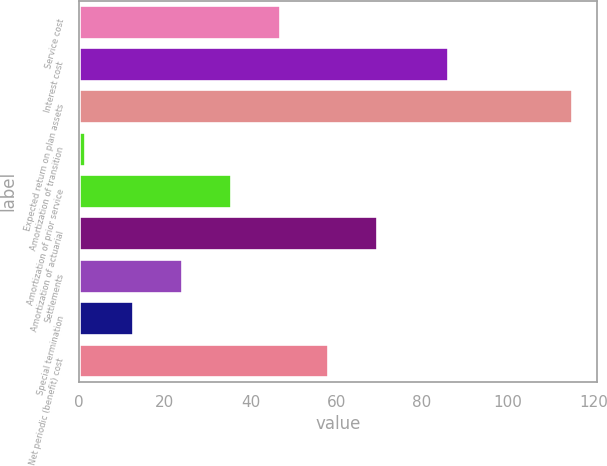Convert chart to OTSL. <chart><loc_0><loc_0><loc_500><loc_500><bar_chart><fcel>Service cost<fcel>Interest cost<fcel>Expected return on plan assets<fcel>Amortization of transition<fcel>Amortization of prior service<fcel>Amortization of actuarial<fcel>Settlements<fcel>Special termination<fcel>Net periodic (benefit) cost<nl><fcel>46.78<fcel>86<fcel>115<fcel>1.3<fcel>35.41<fcel>69.52<fcel>24.04<fcel>12.67<fcel>58.15<nl></chart> 